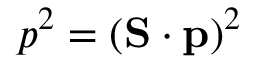Convert formula to latex. <formula><loc_0><loc_0><loc_500><loc_500>p ^ { 2 } = ( S \cdot p ) ^ { 2 }</formula> 